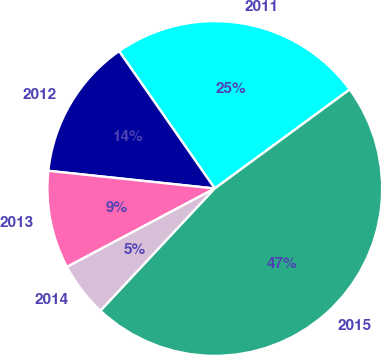<chart> <loc_0><loc_0><loc_500><loc_500><pie_chart><fcel>2011<fcel>2012<fcel>2013<fcel>2014<fcel>2015<nl><fcel>24.61%<fcel>13.63%<fcel>9.45%<fcel>5.27%<fcel>47.04%<nl></chart> 